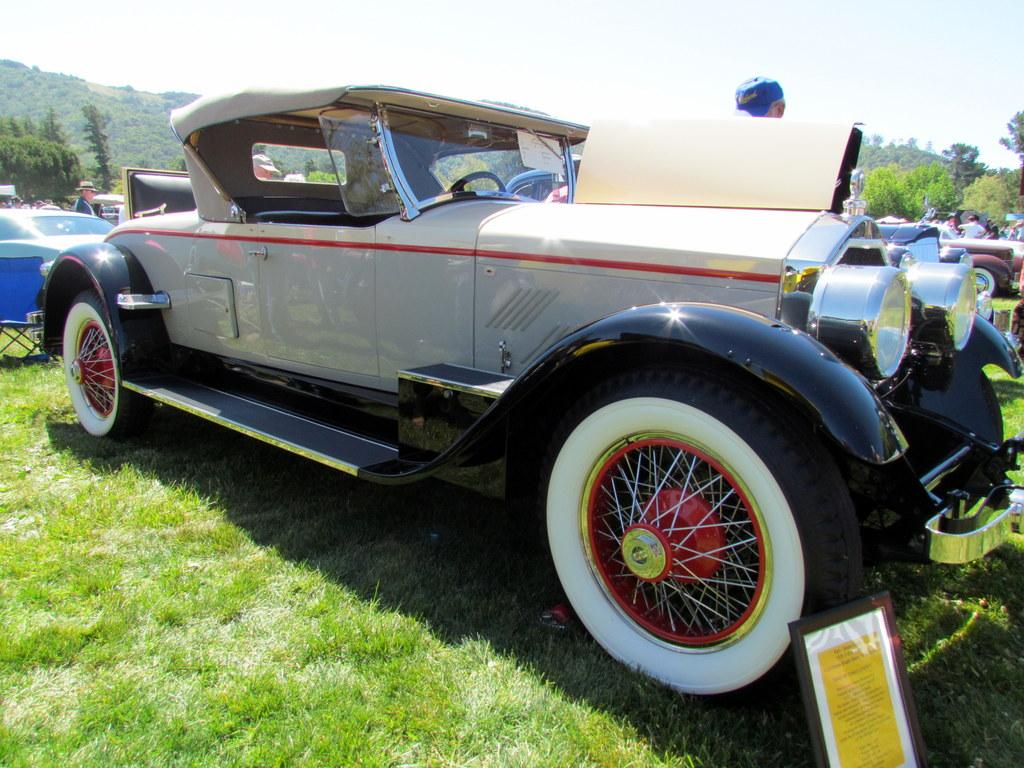What is the main object in the foreground of the image? There is a frame in the image. What type of furniture is present in the image? There is a chair in the image. Where are the vehicles located in the image? The vehicles are on the grass in the image. What can be seen in the background of the image? There is a group of people, trees, some objects, and the sky visible in the background of the image. What type of ants can be seen carrying out a selection process in the image? There are no ants or any selection process visible in the image. What type of war is depicted in the image? There is no war or any conflict depicted in the image. 